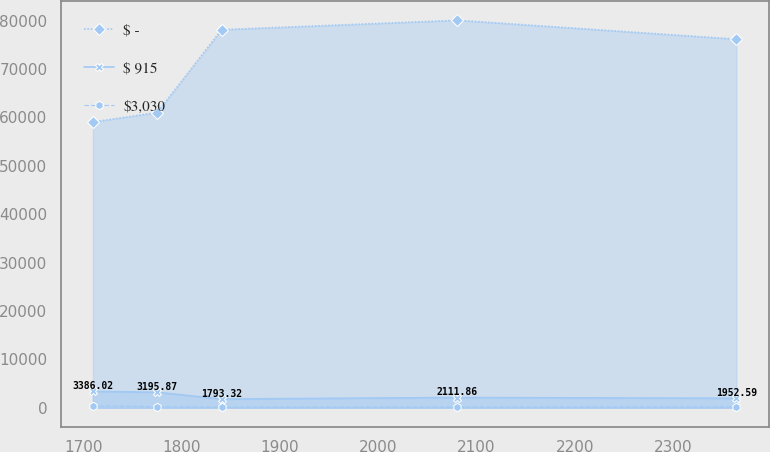<chart> <loc_0><loc_0><loc_500><loc_500><line_chart><ecel><fcel>$ -<fcel>$ 915<fcel>$3,030<nl><fcel>1709.52<fcel>59061.2<fcel>3386.02<fcel>415.47<nl><fcel>1775.04<fcel>61012.6<fcel>3195.87<fcel>203.76<nl><fcel>1840.56<fcel>78136.3<fcel>1793.32<fcel>113.04<nl><fcel>2080.58<fcel>80087.8<fcel>2111.86<fcel>143.28<nl><fcel>2364.68<fcel>76184.9<fcel>1952.59<fcel>173.52<nl></chart> 